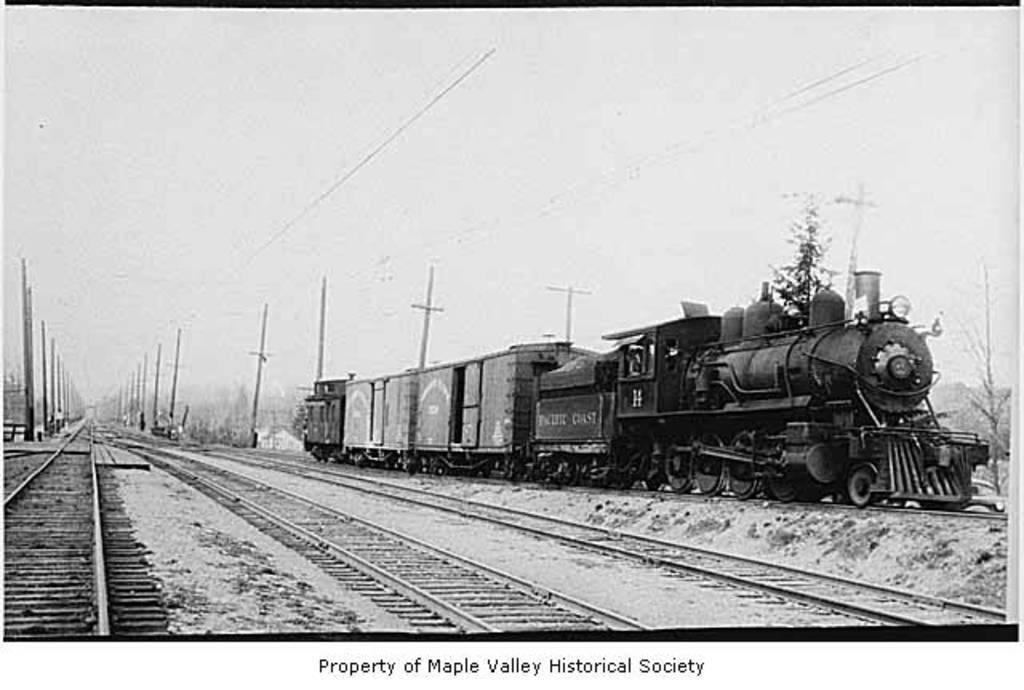Could you give a brief overview of what you see in this image? In this picture we can see a train on a railway track and in the background we can see poles,sky. 